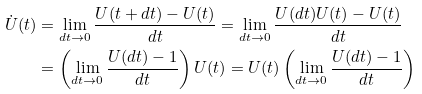Convert formula to latex. <formula><loc_0><loc_0><loc_500><loc_500>\dot { U } ( t ) & = \lim _ { d t \rightarrow 0 } \frac { U ( t + d t ) - U ( t ) } { d t } = \lim _ { d t \rightarrow 0 } \frac { U ( d t ) U ( t ) - U ( t ) } { d t } \\ & = \left ( \lim _ { d t \rightarrow 0 } \frac { U ( d t ) - 1 } { d t } \right ) U ( t ) = U ( t ) \left ( \lim _ { d t \rightarrow 0 } \frac { U ( d t ) - 1 } { d t } \right )</formula> 